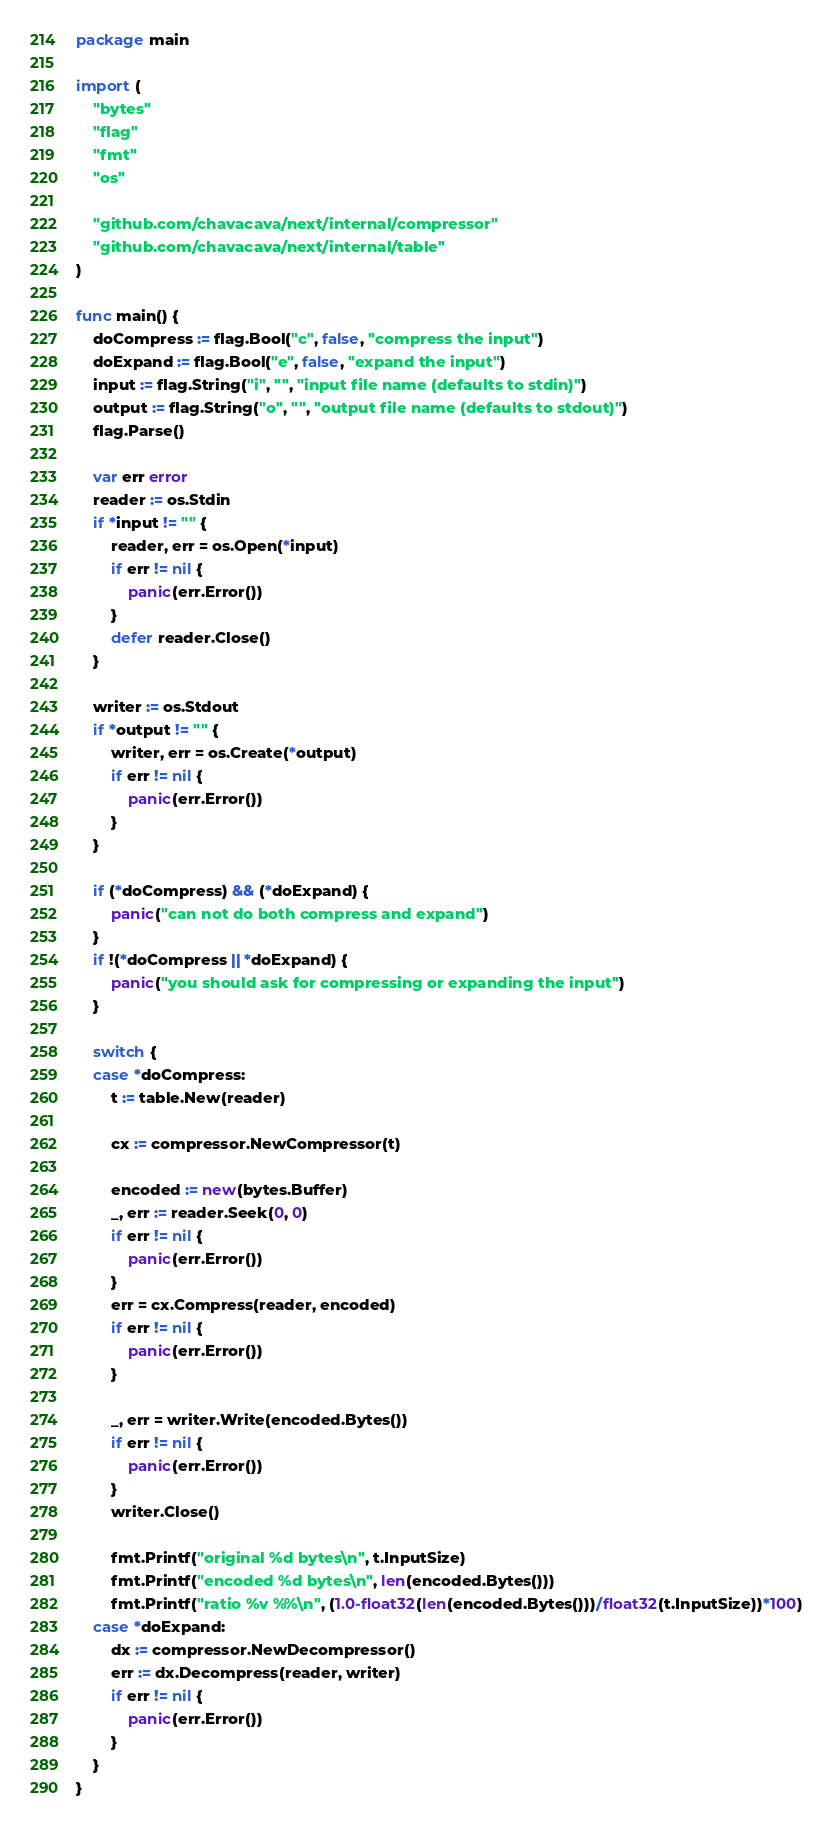<code> <loc_0><loc_0><loc_500><loc_500><_Go_>package main

import (
	"bytes"
	"flag"
	"fmt"
	"os"

	"github.com/chavacava/next/internal/compressor"
	"github.com/chavacava/next/internal/table"
)

func main() {
	doCompress := flag.Bool("c", false, "compress the input")
	doExpand := flag.Bool("e", false, "expand the input")
	input := flag.String("i", "", "input file name (defaults to stdin)")
	output := flag.String("o", "", "output file name (defaults to stdout)")
	flag.Parse()

	var err error
	reader := os.Stdin
	if *input != "" {
		reader, err = os.Open(*input)
		if err != nil {
			panic(err.Error())
		}
		defer reader.Close()
	}

	writer := os.Stdout
	if *output != "" {
		writer, err = os.Create(*output)
		if err != nil {
			panic(err.Error())
		}
	}

	if (*doCompress) && (*doExpand) {
		panic("can not do both compress and expand")
	}
	if !(*doCompress || *doExpand) {
		panic("you should ask for compressing or expanding the input")
	}

	switch {
	case *doCompress:
		t := table.New(reader)

		cx := compressor.NewCompressor(t)

		encoded := new(bytes.Buffer)
		_, err := reader.Seek(0, 0)
		if err != nil {
			panic(err.Error())
		}
		err = cx.Compress(reader, encoded)
		if err != nil {
			panic(err.Error())
		}

		_, err = writer.Write(encoded.Bytes())
		if err != nil {
			panic(err.Error())
		}
		writer.Close()

		fmt.Printf("original %d bytes\n", t.InputSize)
		fmt.Printf("encoded %d bytes\n", len(encoded.Bytes()))
		fmt.Printf("ratio %v %%\n", (1.0-float32(len(encoded.Bytes()))/float32(t.InputSize))*100)
	case *doExpand:
		dx := compressor.NewDecompressor()
		err := dx.Decompress(reader, writer)
		if err != nil {
			panic(err.Error())
		}
	}
}
</code> 